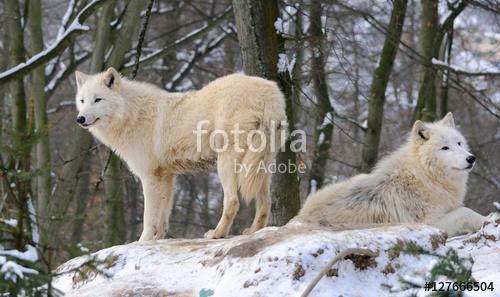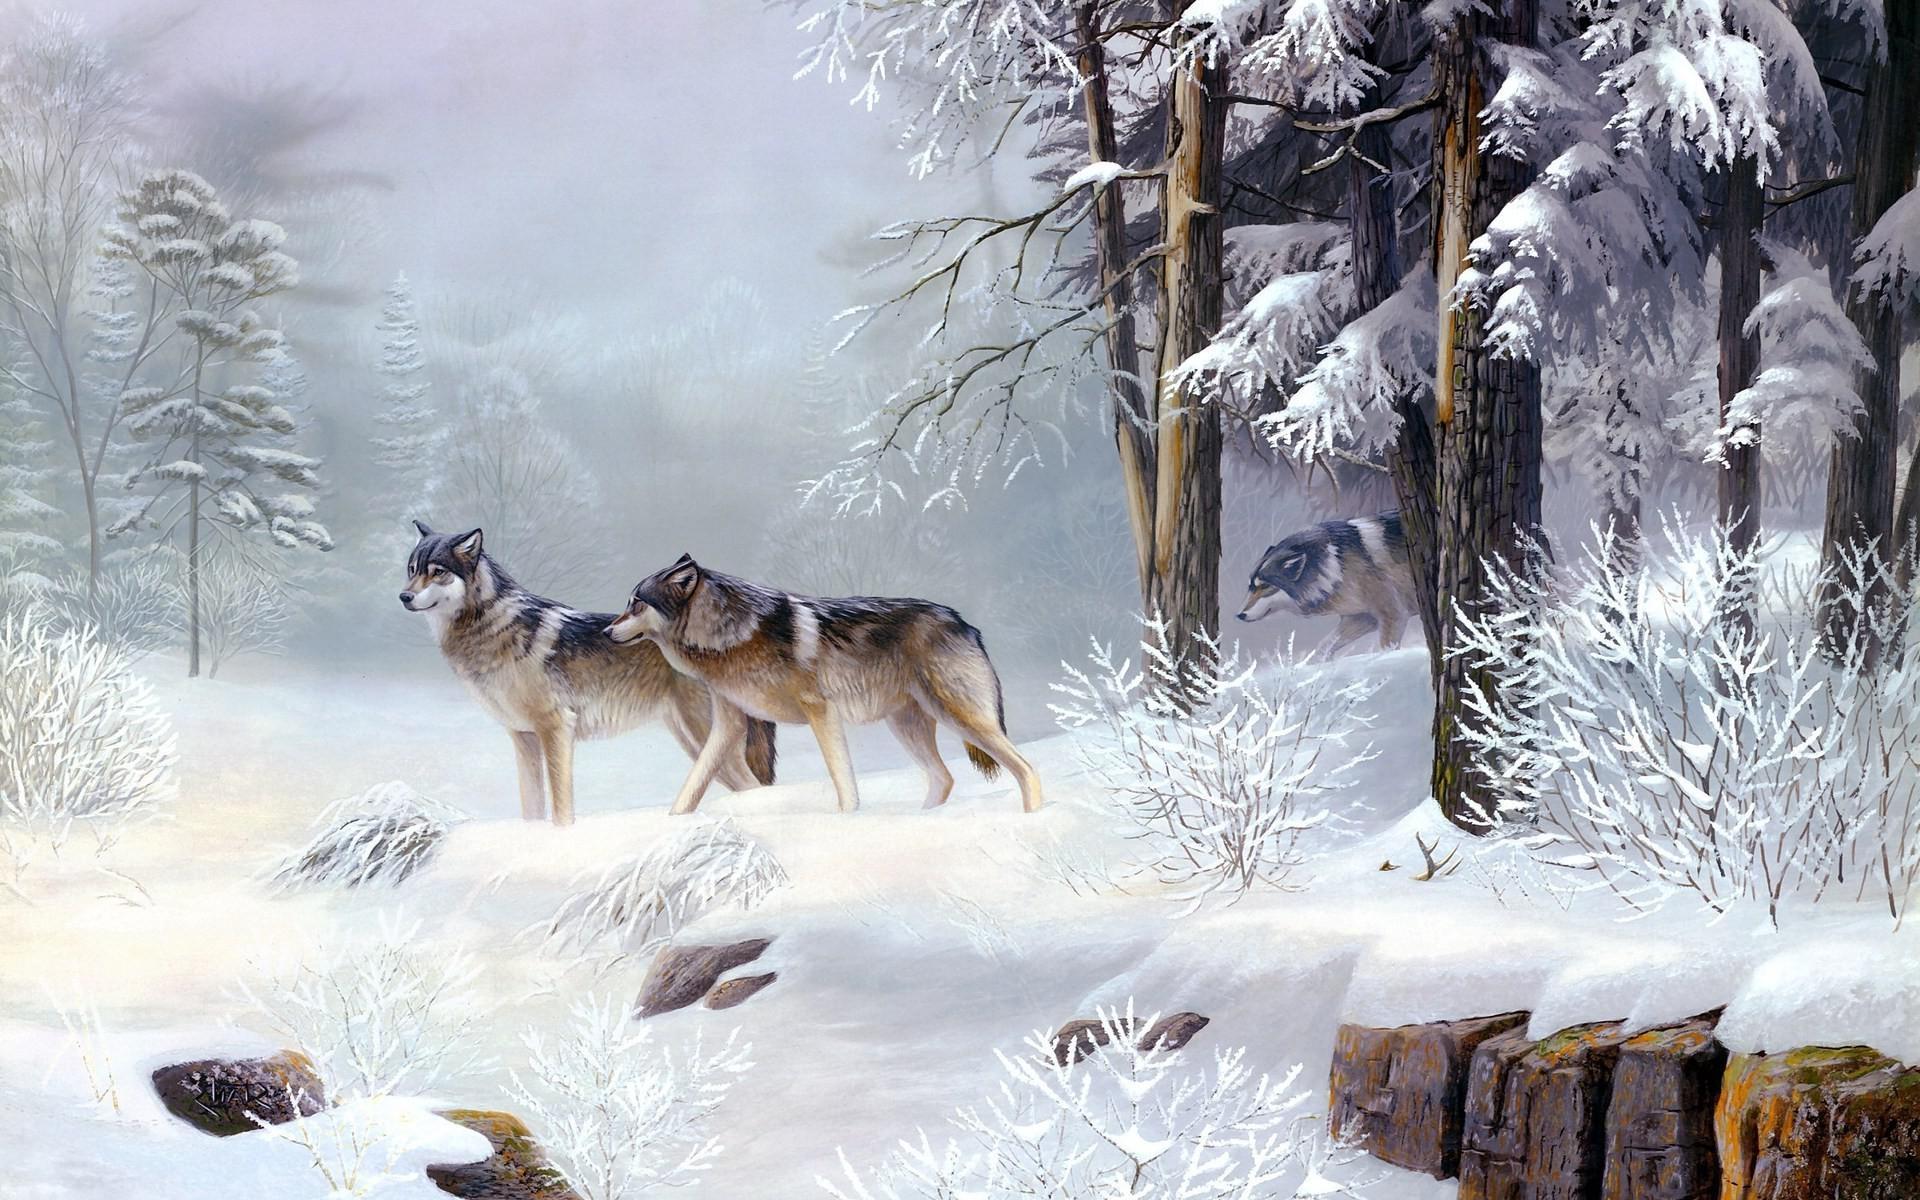The first image is the image on the left, the second image is the image on the right. For the images shown, is this caption "An image shows only two wolves in a snowy scene." true? Answer yes or no. Yes. The first image is the image on the left, the second image is the image on the right. Given the left and right images, does the statement "One image in the set contains exactly 3 wolves, in a snowy setting with at least one tree in the background." hold true? Answer yes or no. Yes. 